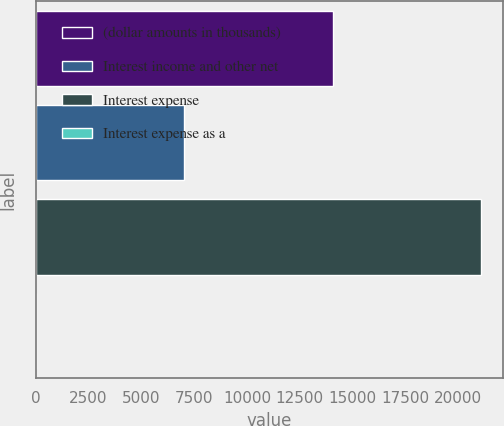Convert chart. <chart><loc_0><loc_0><loc_500><loc_500><bar_chart><fcel>(dollar amounts in thousands)<fcel>Interest income and other net<fcel>Interest expense<fcel>Interest expense as a<nl><fcel>14050.7<fcel>7026.79<fcel>21074.6<fcel>2.88<nl></chart> 